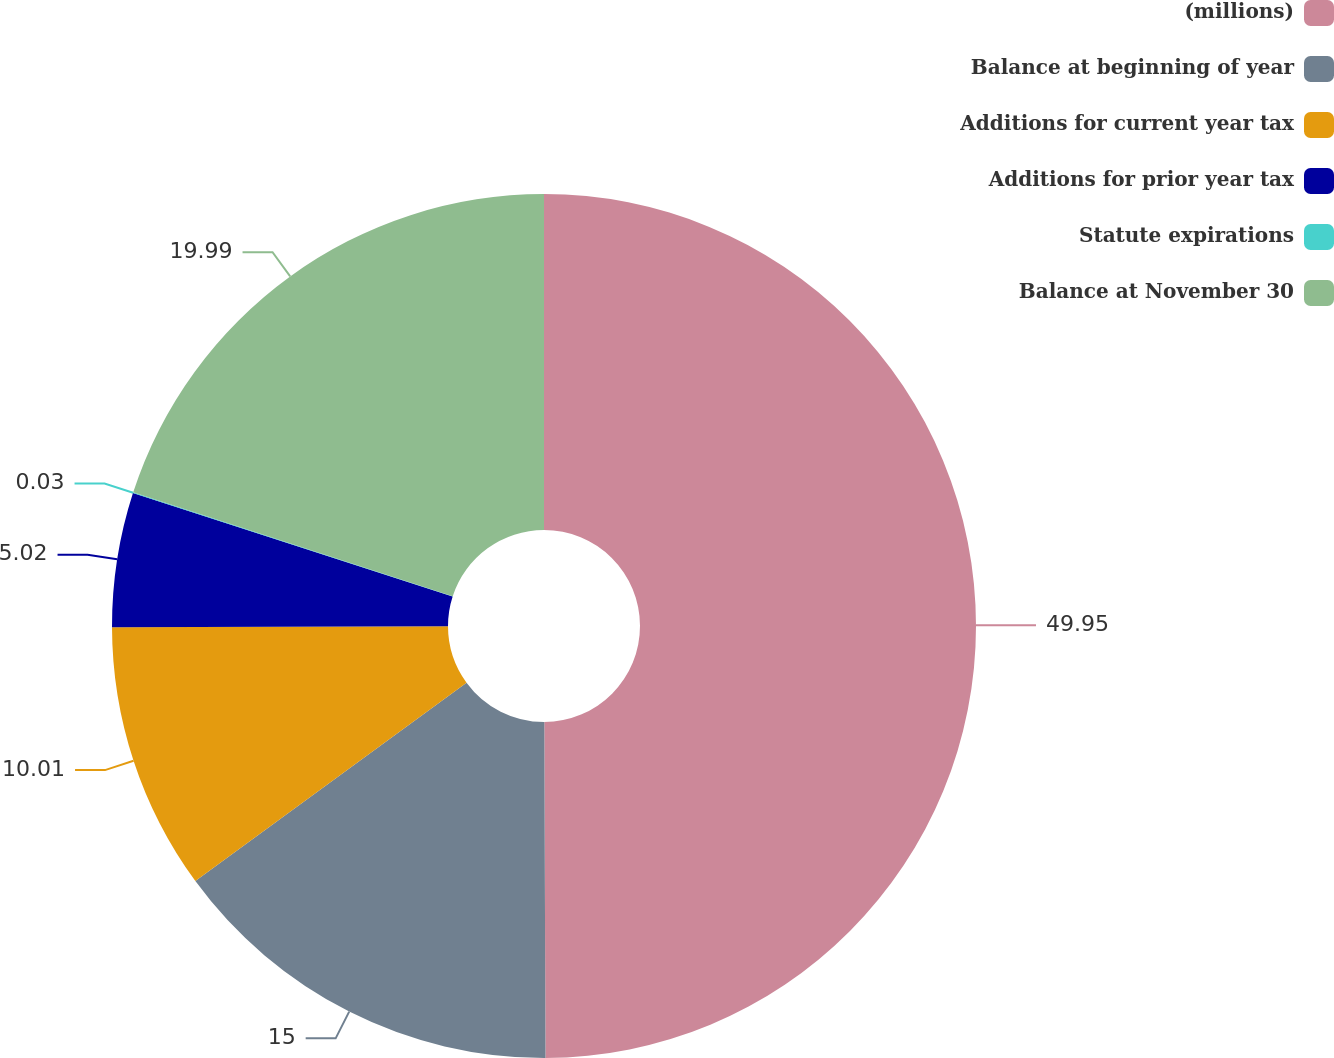<chart> <loc_0><loc_0><loc_500><loc_500><pie_chart><fcel>(millions)<fcel>Balance at beginning of year<fcel>Additions for current year tax<fcel>Additions for prior year tax<fcel>Statute expirations<fcel>Balance at November 30<nl><fcel>49.94%<fcel>15.0%<fcel>10.01%<fcel>5.02%<fcel>0.03%<fcel>19.99%<nl></chart> 